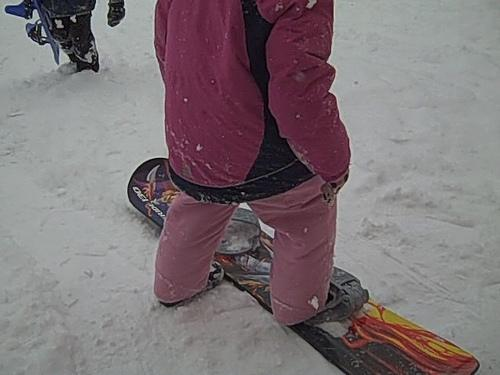How would it be if she tried to snowboard assis?

Choices:
A) too cold
B) too hot
C) no problem
D) too dangerous too dangerous 